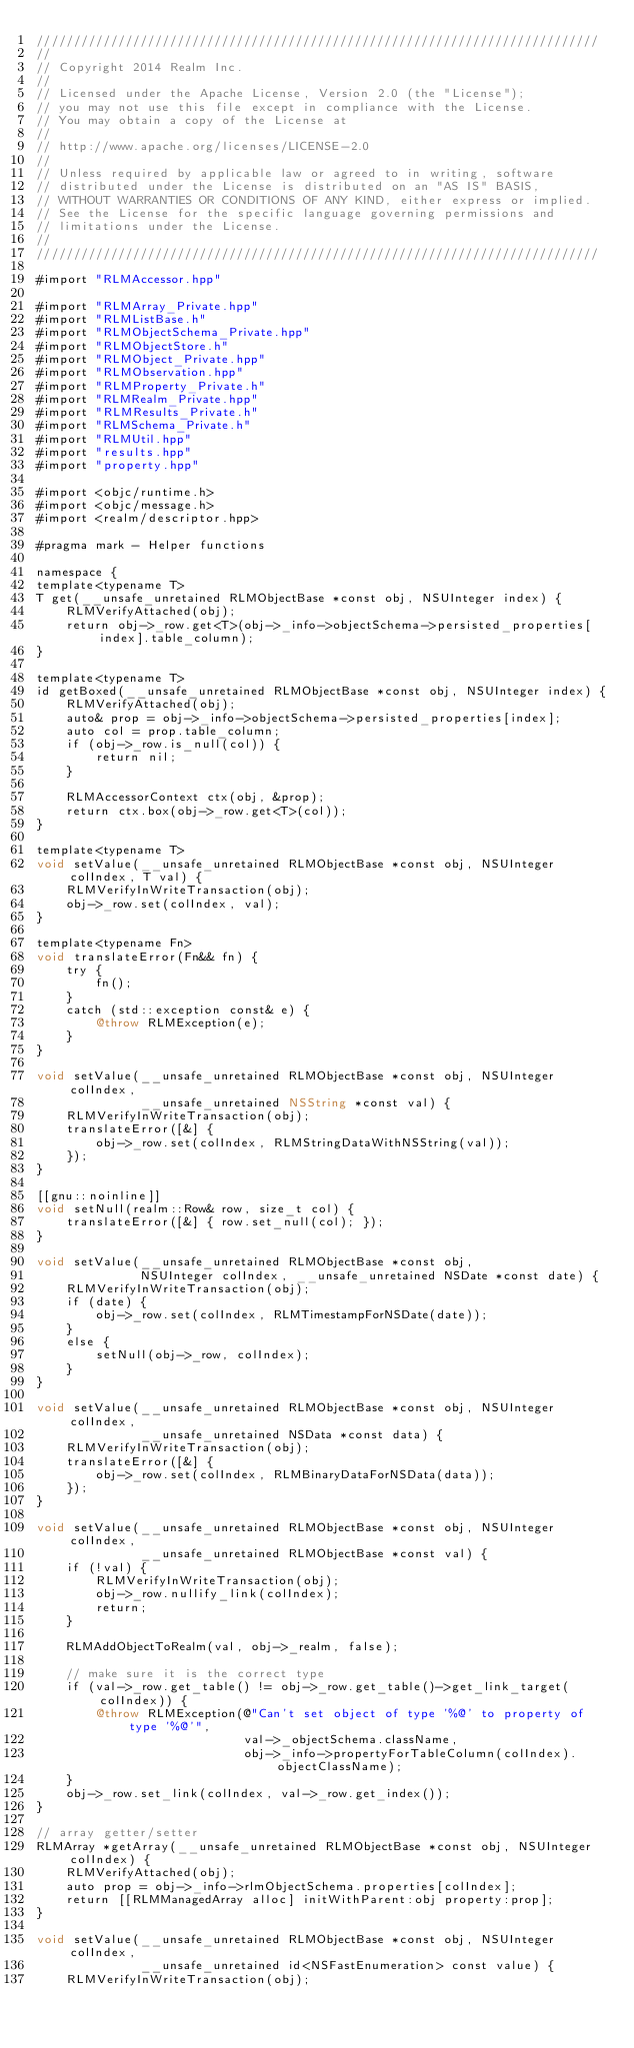Convert code to text. <code><loc_0><loc_0><loc_500><loc_500><_ObjectiveC_>////////////////////////////////////////////////////////////////////////////
//
// Copyright 2014 Realm Inc.
//
// Licensed under the Apache License, Version 2.0 (the "License");
// you may not use this file except in compliance with the License.
// You may obtain a copy of the License at
//
// http://www.apache.org/licenses/LICENSE-2.0
//
// Unless required by applicable law or agreed to in writing, software
// distributed under the License is distributed on an "AS IS" BASIS,
// WITHOUT WARRANTIES OR CONDITIONS OF ANY KIND, either express or implied.
// See the License for the specific language governing permissions and
// limitations under the License.
//
////////////////////////////////////////////////////////////////////////////

#import "RLMAccessor.hpp"

#import "RLMArray_Private.hpp"
#import "RLMListBase.h"
#import "RLMObjectSchema_Private.hpp"
#import "RLMObjectStore.h"
#import "RLMObject_Private.hpp"
#import "RLMObservation.hpp"
#import "RLMProperty_Private.h"
#import "RLMRealm_Private.hpp"
#import "RLMResults_Private.h"
#import "RLMSchema_Private.h"
#import "RLMUtil.hpp"
#import "results.hpp"
#import "property.hpp"

#import <objc/runtime.h>
#import <objc/message.h>
#import <realm/descriptor.hpp>

#pragma mark - Helper functions

namespace {
template<typename T>
T get(__unsafe_unretained RLMObjectBase *const obj, NSUInteger index) {
    RLMVerifyAttached(obj);
    return obj->_row.get<T>(obj->_info->objectSchema->persisted_properties[index].table_column);
}

template<typename T>
id getBoxed(__unsafe_unretained RLMObjectBase *const obj, NSUInteger index) {
    RLMVerifyAttached(obj);
    auto& prop = obj->_info->objectSchema->persisted_properties[index];
    auto col = prop.table_column;
    if (obj->_row.is_null(col)) {
        return nil;
    }

    RLMAccessorContext ctx(obj, &prop);
    return ctx.box(obj->_row.get<T>(col));
}

template<typename T>
void setValue(__unsafe_unretained RLMObjectBase *const obj, NSUInteger colIndex, T val) {
    RLMVerifyInWriteTransaction(obj);
    obj->_row.set(colIndex, val);
}

template<typename Fn>
void translateError(Fn&& fn) {
    try {
        fn();
    }
    catch (std::exception const& e) {
        @throw RLMException(e);
    }
}

void setValue(__unsafe_unretained RLMObjectBase *const obj, NSUInteger colIndex,
              __unsafe_unretained NSString *const val) {
    RLMVerifyInWriteTransaction(obj);
    translateError([&] {
        obj->_row.set(colIndex, RLMStringDataWithNSString(val));
    });
}

[[gnu::noinline]]
void setNull(realm::Row& row, size_t col) {
    translateError([&] { row.set_null(col); });
}

void setValue(__unsafe_unretained RLMObjectBase *const obj,
              NSUInteger colIndex, __unsafe_unretained NSDate *const date) {
    RLMVerifyInWriteTransaction(obj);
    if (date) {
        obj->_row.set(colIndex, RLMTimestampForNSDate(date));
    }
    else {
        setNull(obj->_row, colIndex);
    }
}

void setValue(__unsafe_unretained RLMObjectBase *const obj, NSUInteger colIndex,
              __unsafe_unretained NSData *const data) {
    RLMVerifyInWriteTransaction(obj);
    translateError([&] {
        obj->_row.set(colIndex, RLMBinaryDataForNSData(data));
    });
}

void setValue(__unsafe_unretained RLMObjectBase *const obj, NSUInteger colIndex,
              __unsafe_unretained RLMObjectBase *const val) {
    if (!val) {
        RLMVerifyInWriteTransaction(obj);
        obj->_row.nullify_link(colIndex);
        return;
    }

    RLMAddObjectToRealm(val, obj->_realm, false);

    // make sure it is the correct type
    if (val->_row.get_table() != obj->_row.get_table()->get_link_target(colIndex)) {
        @throw RLMException(@"Can't set object of type '%@' to property of type '%@'",
                            val->_objectSchema.className,
                            obj->_info->propertyForTableColumn(colIndex).objectClassName);
    }
    obj->_row.set_link(colIndex, val->_row.get_index());
}

// array getter/setter
RLMArray *getArray(__unsafe_unretained RLMObjectBase *const obj, NSUInteger colIndex) {
    RLMVerifyAttached(obj);
    auto prop = obj->_info->rlmObjectSchema.properties[colIndex];
    return [[RLMManagedArray alloc] initWithParent:obj property:prop];
}

void setValue(__unsafe_unretained RLMObjectBase *const obj, NSUInteger colIndex,
              __unsafe_unretained id<NSFastEnumeration> const value) {
    RLMVerifyInWriteTransaction(obj);
</code> 